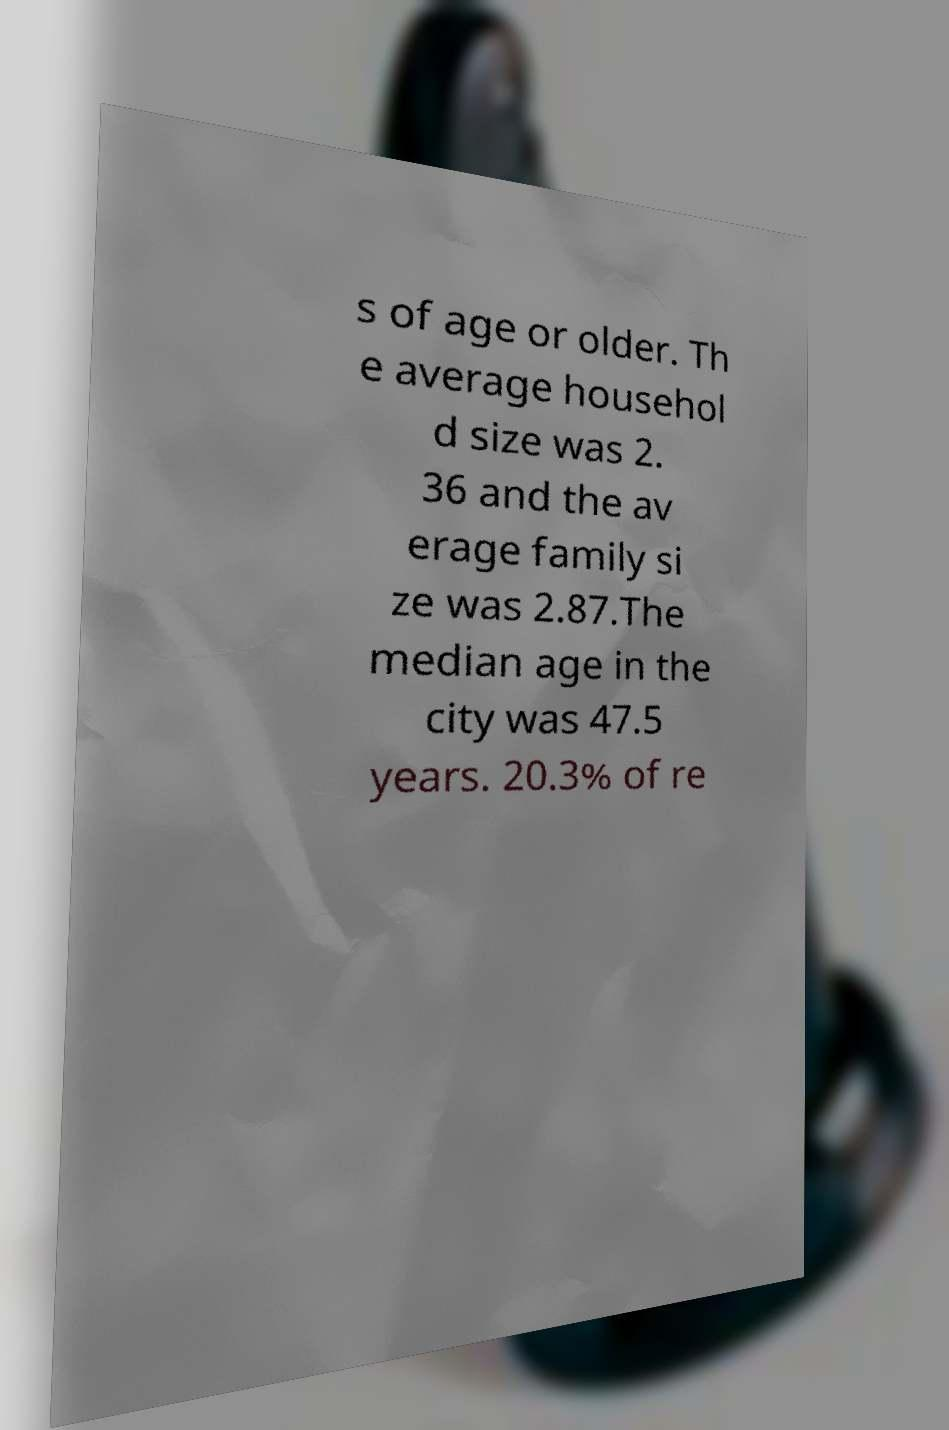Can you accurately transcribe the text from the provided image for me? s of age or older. Th e average househol d size was 2. 36 and the av erage family si ze was 2.87.The median age in the city was 47.5 years. 20.3% of re 